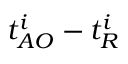<formula> <loc_0><loc_0><loc_500><loc_500>t _ { A O } ^ { i } - t _ { R } ^ { i }</formula> 